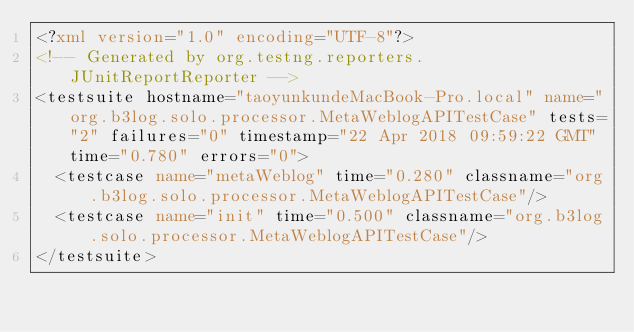<code> <loc_0><loc_0><loc_500><loc_500><_XML_><?xml version="1.0" encoding="UTF-8"?>
<!-- Generated by org.testng.reporters.JUnitReportReporter -->
<testsuite hostname="taoyunkundeMacBook-Pro.local" name="org.b3log.solo.processor.MetaWeblogAPITestCase" tests="2" failures="0" timestamp="22 Apr 2018 09:59:22 GMT" time="0.780" errors="0">
  <testcase name="metaWeblog" time="0.280" classname="org.b3log.solo.processor.MetaWeblogAPITestCase"/>
  <testcase name="init" time="0.500" classname="org.b3log.solo.processor.MetaWeblogAPITestCase"/>
</testsuite>
</code> 